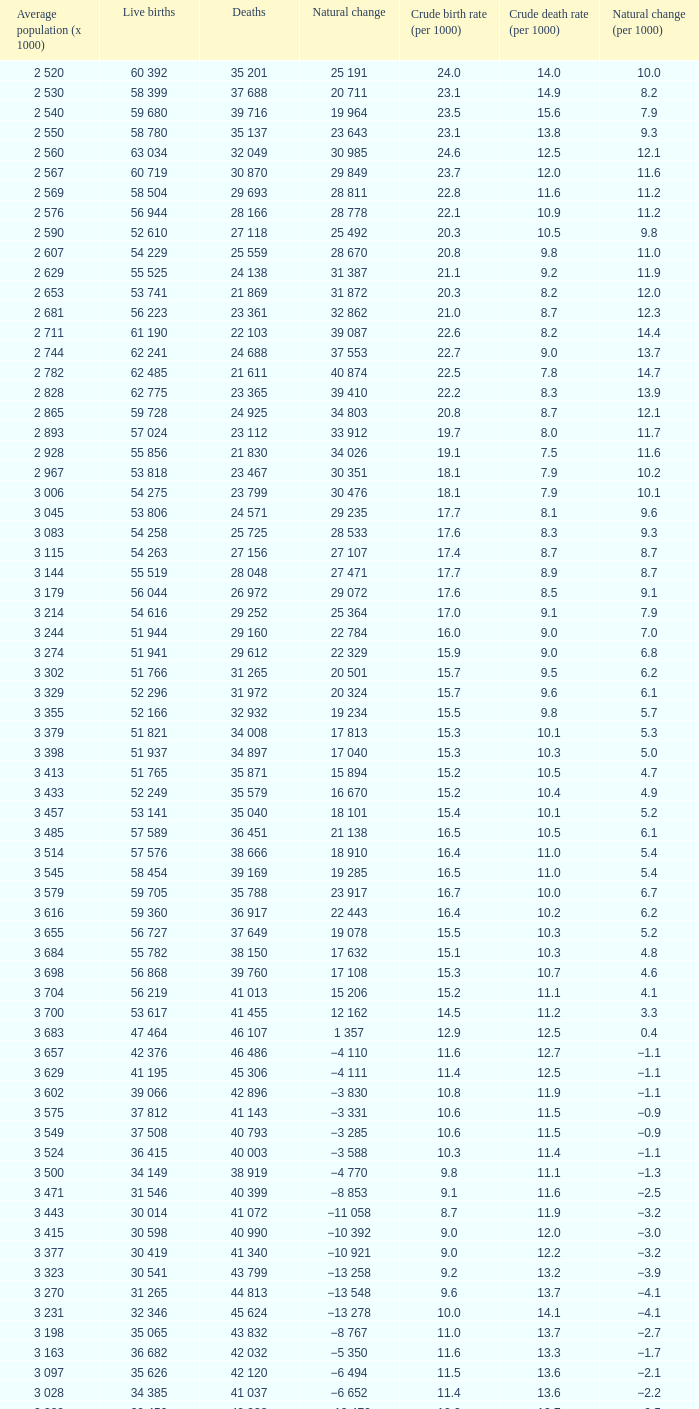9, and a crude birth rate (per 1000) lower than 1 3 115. 